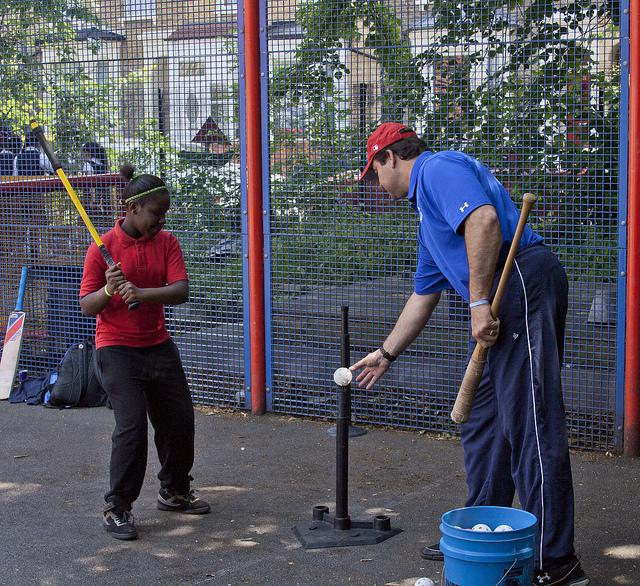What is the black pole the white ball is on called?

Choices:
A) steady hit
B) batting tee
C) pitcher's mound
D) street pole batting tee 